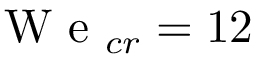<formula> <loc_0><loc_0><loc_500><loc_500>W e _ { c r } = 1 2</formula> 